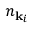Convert formula to latex. <formula><loc_0><loc_0><loc_500><loc_500>n _ { { k } _ { i } }</formula> 